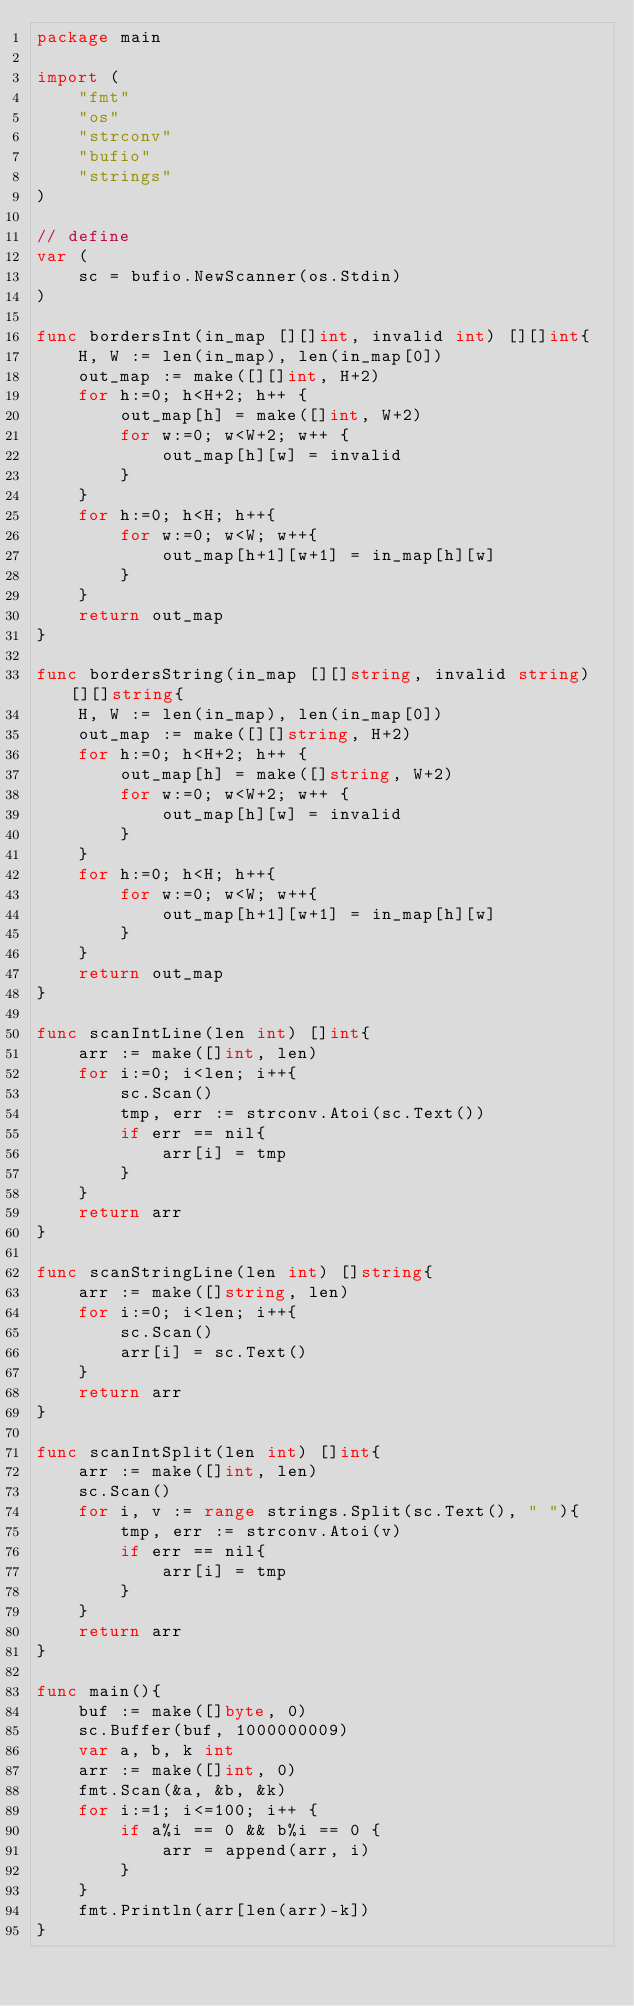<code> <loc_0><loc_0><loc_500><loc_500><_Go_>package main

import (
	"fmt"
	"os"
	"strconv"
	"bufio"
	"strings"
)

// define
var (
	sc = bufio.NewScanner(os.Stdin)
)

func bordersInt(in_map [][]int, invalid int) [][]int{
	H, W := len(in_map), len(in_map[0])
	out_map := make([][]int, H+2)
	for h:=0; h<H+2; h++ {
		out_map[h] = make([]int, W+2)
		for w:=0; w<W+2; w++ {
			out_map[h][w] = invalid
		}
	}
	for h:=0; h<H; h++{
		for w:=0; w<W; w++{
			out_map[h+1][w+1] = in_map[h][w] 
		}
	}
	return out_map
}

func bordersString(in_map [][]string, invalid string) [][]string{
	H, W := len(in_map), len(in_map[0])
	out_map := make([][]string, H+2)
	for h:=0; h<H+2; h++ {
		out_map[h] = make([]string, W+2)
		for w:=0; w<W+2; w++ {
			out_map[h][w] = invalid
		}
	}
	for h:=0; h<H; h++{
		for w:=0; w<W; w++{
			out_map[h+1][w+1] = in_map[h][w] 
		}
	}
	return out_map
}

func scanIntLine(len int) []int{
	arr := make([]int, len)
	for i:=0; i<len; i++{
		sc.Scan()
		tmp, err := strconv.Atoi(sc.Text())
		if err == nil{
			arr[i] = tmp
		}
	}
	return arr
}

func scanStringLine(len int) []string{
	arr := make([]string, len)
	for i:=0; i<len; i++{
		sc.Scan()
		arr[i] = sc.Text()
	}
	return arr
}

func scanIntSplit(len int) []int{
	arr := make([]int, len)
	sc.Scan()
	for i, v := range strings.Split(sc.Text(), " "){
		tmp, err := strconv.Atoi(v)
		if err == nil{
			arr[i] = tmp
		}
	}
	return arr
}

func main(){
	buf := make([]byte, 0)
	sc.Buffer(buf, 1000000009)
	var a, b, k int
	arr := make([]int, 0)
	fmt.Scan(&a, &b, &k)
	for i:=1; i<=100; i++ {
		if a%i == 0 && b%i == 0 {
			arr = append(arr, i)
		}
	}
	fmt.Println(arr[len(arr)-k])
}</code> 